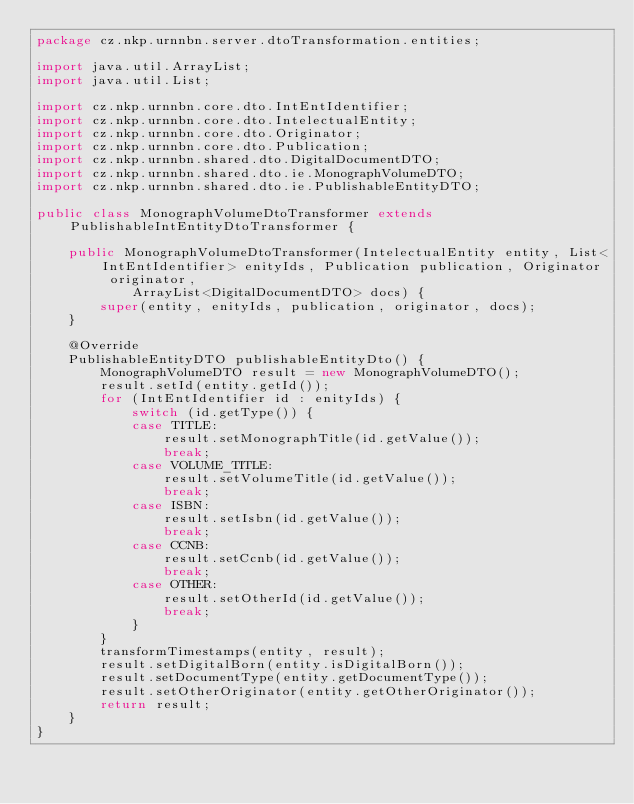Convert code to text. <code><loc_0><loc_0><loc_500><loc_500><_Java_>package cz.nkp.urnnbn.server.dtoTransformation.entities;

import java.util.ArrayList;
import java.util.List;

import cz.nkp.urnnbn.core.dto.IntEntIdentifier;
import cz.nkp.urnnbn.core.dto.IntelectualEntity;
import cz.nkp.urnnbn.core.dto.Originator;
import cz.nkp.urnnbn.core.dto.Publication;
import cz.nkp.urnnbn.shared.dto.DigitalDocumentDTO;
import cz.nkp.urnnbn.shared.dto.ie.MonographVolumeDTO;
import cz.nkp.urnnbn.shared.dto.ie.PublishableEntityDTO;

public class MonographVolumeDtoTransformer extends PublishableIntEntityDtoTransformer {

    public MonographVolumeDtoTransformer(IntelectualEntity entity, List<IntEntIdentifier> enityIds, Publication publication, Originator originator,
            ArrayList<DigitalDocumentDTO> docs) {
        super(entity, enityIds, publication, originator, docs);
    }

    @Override
    PublishableEntityDTO publishableEntityDto() {
        MonographVolumeDTO result = new MonographVolumeDTO();
        result.setId(entity.getId());
        for (IntEntIdentifier id : enityIds) {
            switch (id.getType()) {
            case TITLE:
                result.setMonographTitle(id.getValue());
                break;
            case VOLUME_TITLE:
                result.setVolumeTitle(id.getValue());
                break;
            case ISBN:
                result.setIsbn(id.getValue());
                break;
            case CCNB:
                result.setCcnb(id.getValue());
                break;
            case OTHER:
                result.setOtherId(id.getValue());
                break;
            }
        }
        transformTimestamps(entity, result);
        result.setDigitalBorn(entity.isDigitalBorn());
        result.setDocumentType(entity.getDocumentType());
        result.setOtherOriginator(entity.getOtherOriginator());
        return result;
    }
}
</code> 